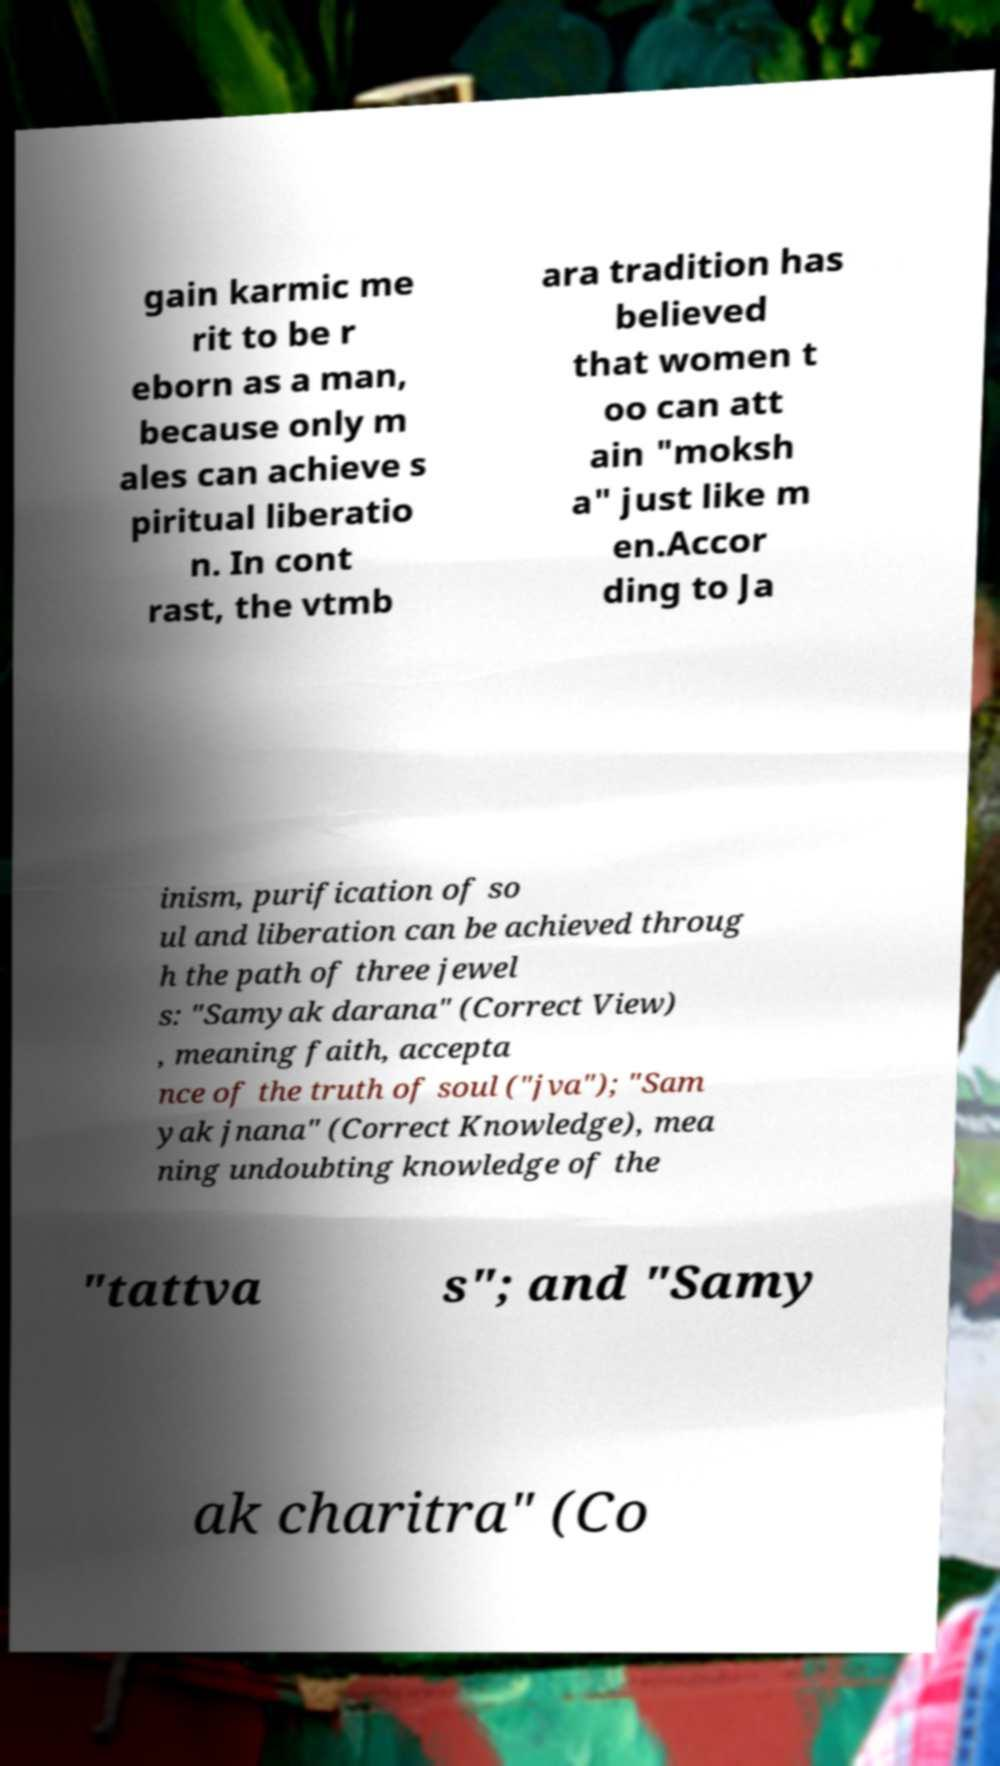For documentation purposes, I need the text within this image transcribed. Could you provide that? gain karmic me rit to be r eborn as a man, because only m ales can achieve s piritual liberatio n. In cont rast, the vtmb ara tradition has believed that women t oo can att ain "moksh a" just like m en.Accor ding to Ja inism, purification of so ul and liberation can be achieved throug h the path of three jewel s: "Samyak darana" (Correct View) , meaning faith, accepta nce of the truth of soul ("jva"); "Sam yak jnana" (Correct Knowledge), mea ning undoubting knowledge of the "tattva s"; and "Samy ak charitra" (Co 